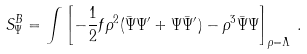Convert formula to latex. <formula><loc_0><loc_0><loc_500><loc_500>S ^ { B } _ { \Psi } = \int \left [ - \frac { 1 } { 2 } f \rho ^ { 2 } ( \bar { \Psi } \Psi ^ { \prime } + \Psi \bar { \Psi } ^ { \prime } ) - \rho ^ { 3 } \bar { \Psi } \Psi \right ] _ { \rho = \Lambda } \, .</formula> 